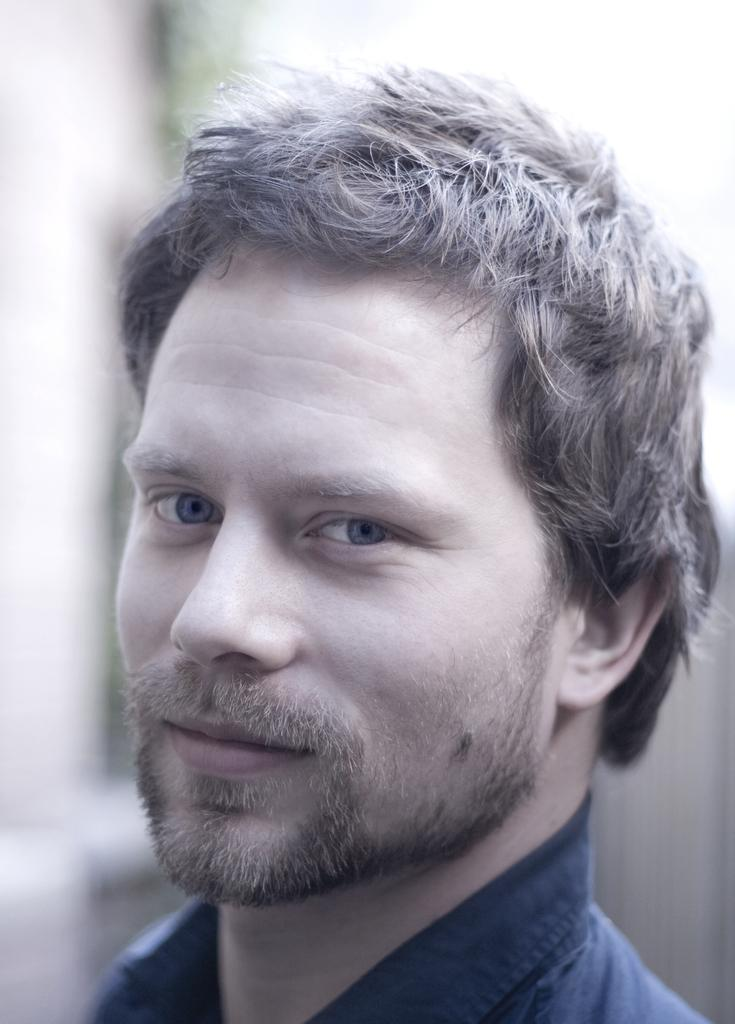Who is present in the image? There is a man in the image. What can be observed about the background of the image? The background of the image is blurred. What type of dog is sitting on the calendar in the image? There is no dog or calendar present in the image. What kind of trouble is the man experiencing in the image? There is no indication of trouble in the image; it only shows a man with a blurred background. 